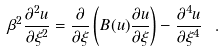<formula> <loc_0><loc_0><loc_500><loc_500>\beta ^ { 2 } \frac { \partial ^ { 2 } u } { \partial \xi ^ { 2 } } = \frac { \partial } { \partial \xi } \left ( B ( u ) \frac { \partial u } { \partial \xi } \right ) - \frac { \partial ^ { 4 } u } { \partial \xi ^ { 4 } } \ .</formula> 